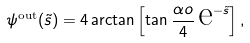<formula> <loc_0><loc_0><loc_500><loc_500>\psi ^ { \text {out} } ( \tilde { s } ) = 4 \arctan { \left [ \tan { \frac { \alpha o } { 4 } } \, \text {e} ^ { - \tilde { s } } \right ] } \, ,</formula> 